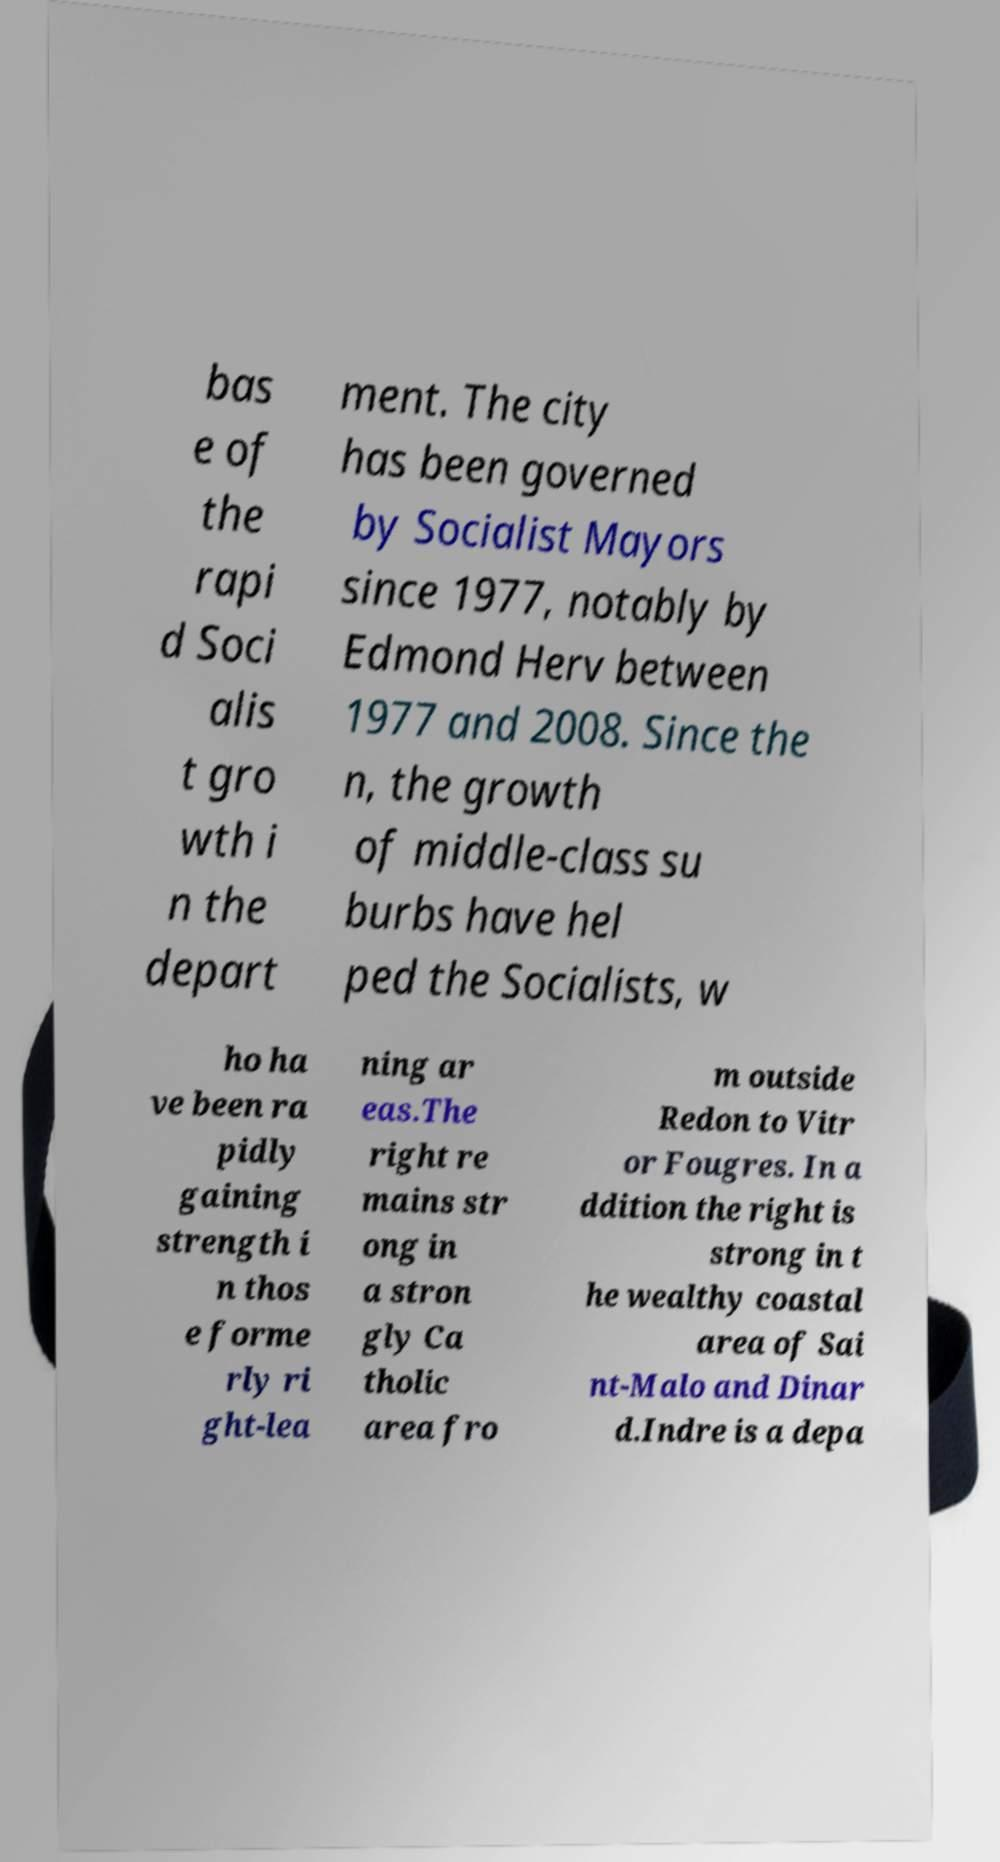There's text embedded in this image that I need extracted. Can you transcribe it verbatim? bas e of the rapi d Soci alis t gro wth i n the depart ment. The city has been governed by Socialist Mayors since 1977, notably by Edmond Herv between 1977 and 2008. Since the n, the growth of middle-class su burbs have hel ped the Socialists, w ho ha ve been ra pidly gaining strength i n thos e forme rly ri ght-lea ning ar eas.The right re mains str ong in a stron gly Ca tholic area fro m outside Redon to Vitr or Fougres. In a ddition the right is strong in t he wealthy coastal area of Sai nt-Malo and Dinar d.Indre is a depa 